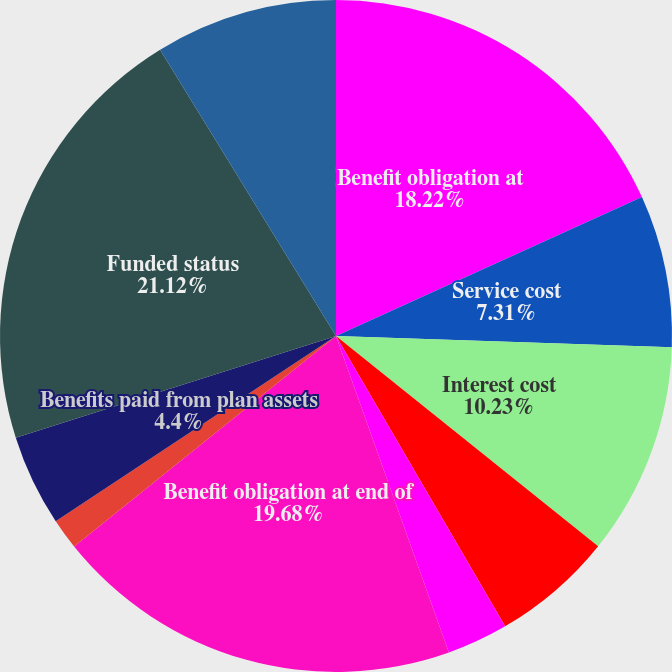Convert chart to OTSL. <chart><loc_0><loc_0><loc_500><loc_500><pie_chart><fcel>Benefit obligation at<fcel>Service cost<fcel>Interest cost<fcel>Actuarial loss (gain)<fcel>Benefits paid<fcel>Benefit obligation at end of<fcel>Employer contributions<fcel>Benefits paid from plan assets<fcel>Funded status<fcel>Unrecognized net actuarial<nl><fcel>18.22%<fcel>7.31%<fcel>10.23%<fcel>5.85%<fcel>2.94%<fcel>19.68%<fcel>1.48%<fcel>4.4%<fcel>21.13%<fcel>8.77%<nl></chart> 